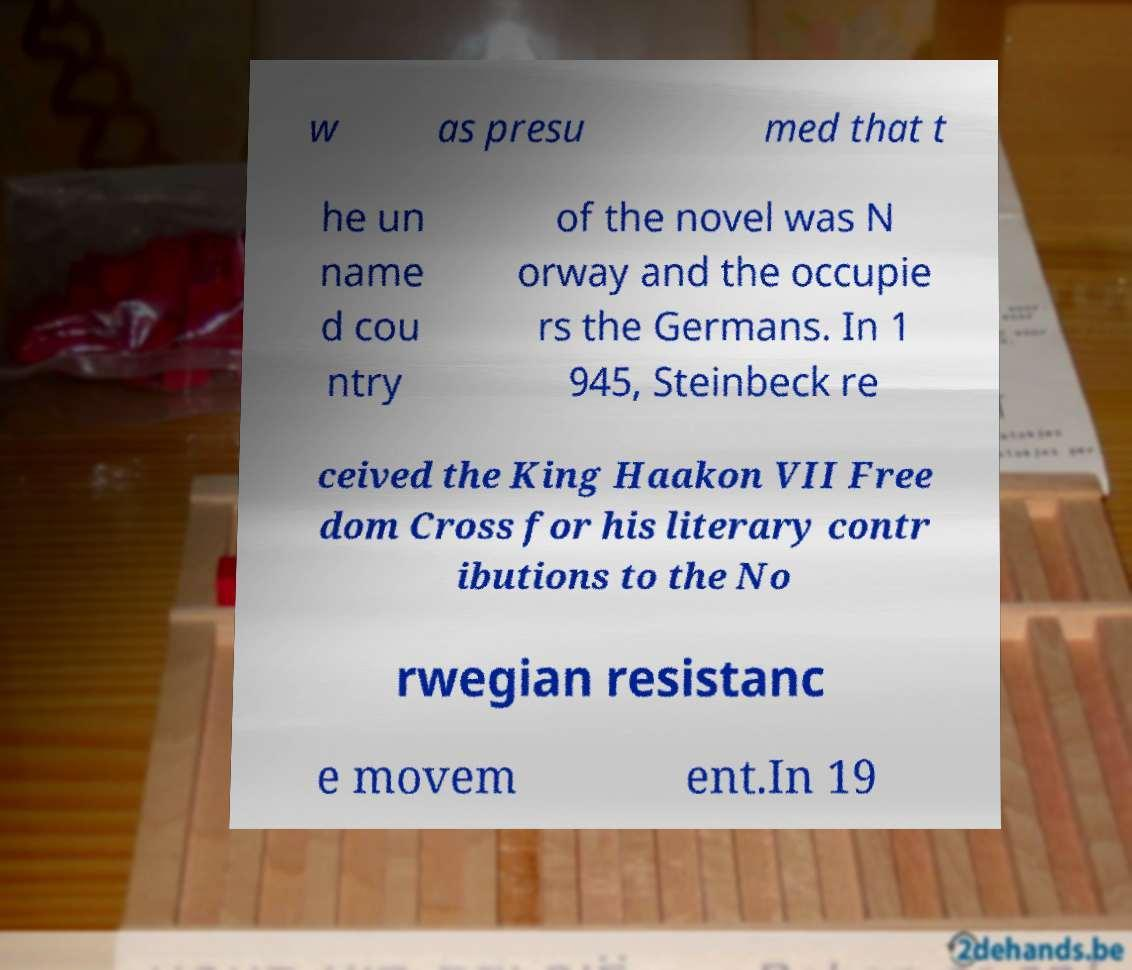There's text embedded in this image that I need extracted. Can you transcribe it verbatim? w as presu med that t he un name d cou ntry of the novel was N orway and the occupie rs the Germans. In 1 945, Steinbeck re ceived the King Haakon VII Free dom Cross for his literary contr ibutions to the No rwegian resistanc e movem ent.In 19 